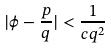<formula> <loc_0><loc_0><loc_500><loc_500>| \phi - \frac { p } { q } | < \frac { 1 } { c q ^ { 2 } }</formula> 